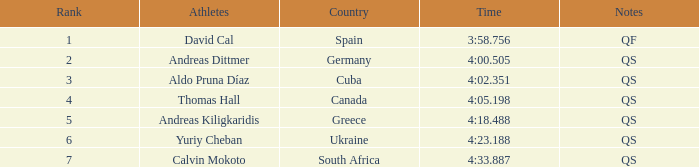In terms of rank, where does andreas kiligkaridis stand? 5.0. 